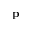Convert formula to latex. <formula><loc_0><loc_0><loc_500><loc_500>p</formula> 